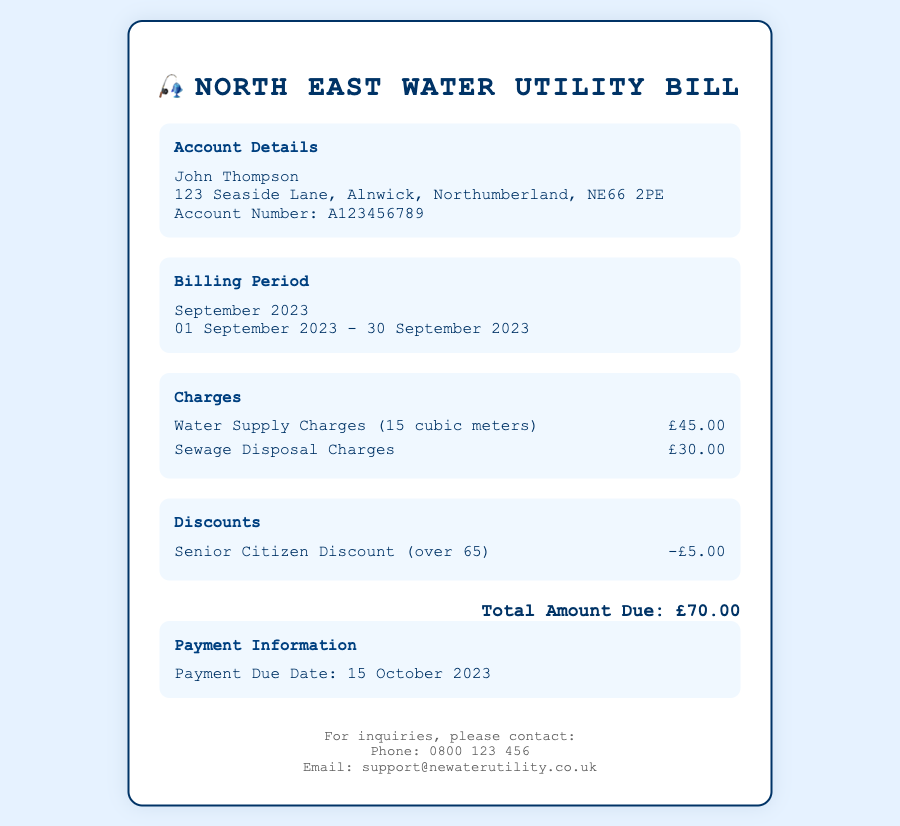What is the account holder's name? The account holder's name is prominently listed in the document as "John Thompson."
Answer: John Thompson What is the billing period for this utility bill? The billing period is specified in the document as the duration from "01 September 2023 - 30 September 2023."
Answer: September 2023 How much is charged for water supply? The charge for water supply is clearly mentioned in the charges section as "£45.00."
Answer: £45.00 What discount is applied for senior citizens? The document states that a senior citizen discount of "£5.00" is given.
Answer: £5.00 What is the total amount due? The total amount due is summarized in the document as "£70.00."
Answer: £70.00 When is the payment due date? The payment due date is provided in the payment information section as "15 October 2023."
Answer: 15 October 2023 What is the address of the account holder? The address of the account holder is listed as "123 Seaside Lane, Alnwick, Northumberland, NE66 2PE."
Answer: 123 Seaside Lane, Alnwick, Northumberland, NE66 2PE How many cubic meters of water were billed? The document specifies that water supply charges were for "15 cubic meters."
Answer: 15 cubic meters What is the charge for sewage disposal? The charge for sewage disposal is detailed as "£30.00" in the charges section.
Answer: £30.00 